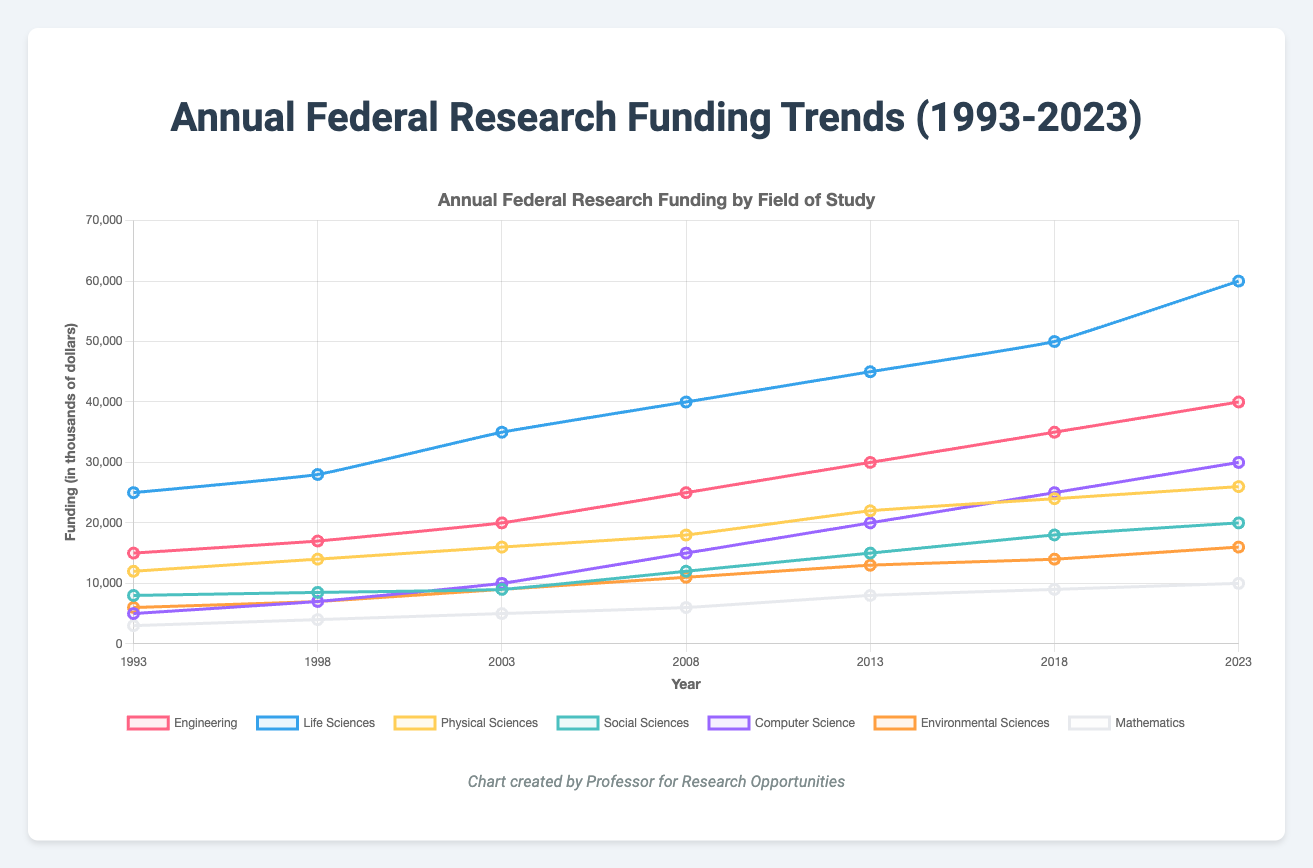What is the overall trend in research funding for Life Sciences from 1993 to 2023? The plot shows a consistent increase in funding for Life Sciences over the years. In 1993, funding was $25,000, and it steadily increased to $60,000 by 2023.
Answer: Steady increase Which field received the highest funding in 2023? By looking at the endpoints of the lines in 2023, Life Sciences has the highest funding at $60,000.
Answer: Life Sciences Compare the funding for Computer Science and Mathematics in 2018. In the year 2018, the funding for Computer Science was $25,000, while for Mathematics, it was $9,000. Comparing these, Computer Science received more funding.
Answer: Computer Science What is the difference in funding between Engineering and Environmental Sciences in 2008? In 2008, Engineering received $25,000 and Environmental Sciences received $11,000. The difference is $25,000 - $11,000.
Answer: $14,000 Which field experienced the largest increase in funding from 1993 to 2023? By calculating the increase for each field: Engineering ($40,000 - $15,000 = $25,000), Life Sciences ($60,000 - $25,000 = $35,000), Physical Sciences ($26,000 - $12,000 = $14,000), Social Sciences ($20,000 - $8,000 = $12,000), Computer Science ($30,000 - $5,000 = $25,000), Environmental Sciences ($16,000 - $6,000 = $10,000), Mathematics ($10,000 - $3,000 = $7,000). Life Sciences has the largest increase.
Answer: Life Sciences What can you say about the trend in funding for Physical Sciences over the entire period? From the graph, Physical Sciences shows a steady upward trend, starting from $12,000 in 1993 and reaching $26,000 in 2023 with consistent increments in between.
Answer: Steady increase How did funding for Social Sciences change between 1998 and 2013? In 1998, funding was $8,500, and by 2013 it increased to $15,000. The change is $15,000 - $8,500.
Answer: Increased by $6,500 What was the sum of funding for Engineering and Computer Science in 2023? In 2023, Engineering received $40,000 and Computer Science received $30,000. The sum is $40,000 + $30,000.
Answer: $70,000 What visual clue does the chart use to differentiate different fields of study? The chart uses different colors for each field of study, with distinct line colors to differentiate them.
Answer: Different colors By how much did funding for Mathematics grow from 1993 to 2023? In 1993, the funding for Mathematics was $3,000, and in 2023, it was $10,000. The growth is $10,000 - $3,000.
Answer: $7,000 